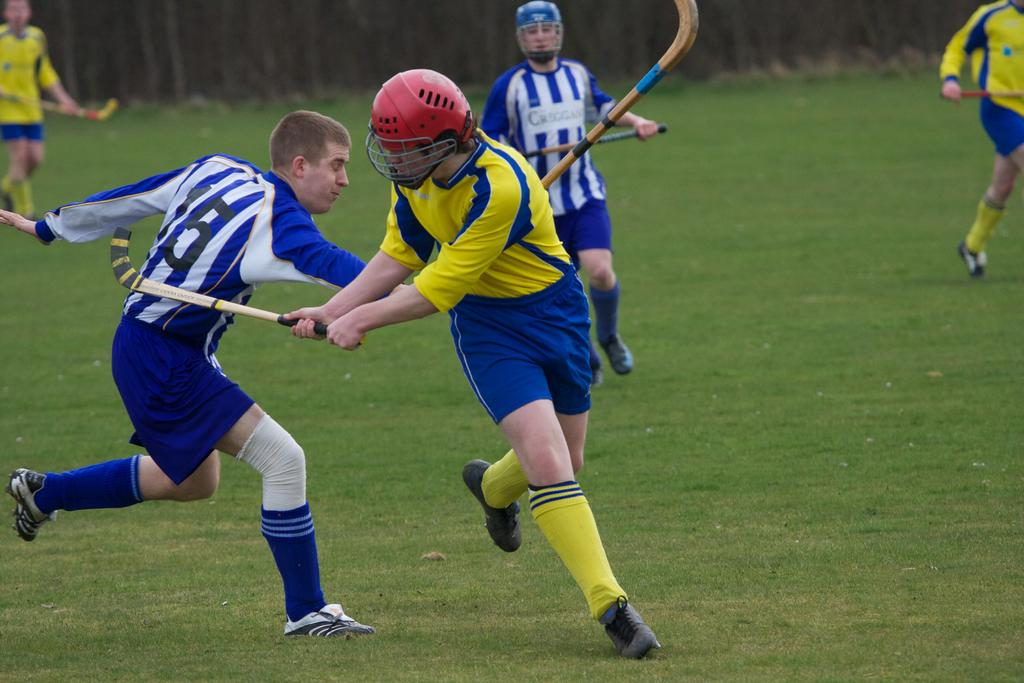What is happening in the image involving the group of people? The people in the image are holding bats and running on the ground. What protective gear are some of the people wearing? Two of the people are wearing helmets. What can be inferred about the activity the group of people is engaged in? The presence of bats and the act of running suggest that they might be playing a sport, such as baseball or cricket. What grade is the teacher giving to the students in the image? There is no teacher or students present in the image, and therefore no grade can be given. What type of glove is being used by the people in the image? There is no glove visible in the image; the people are holding bats and running on the ground. 